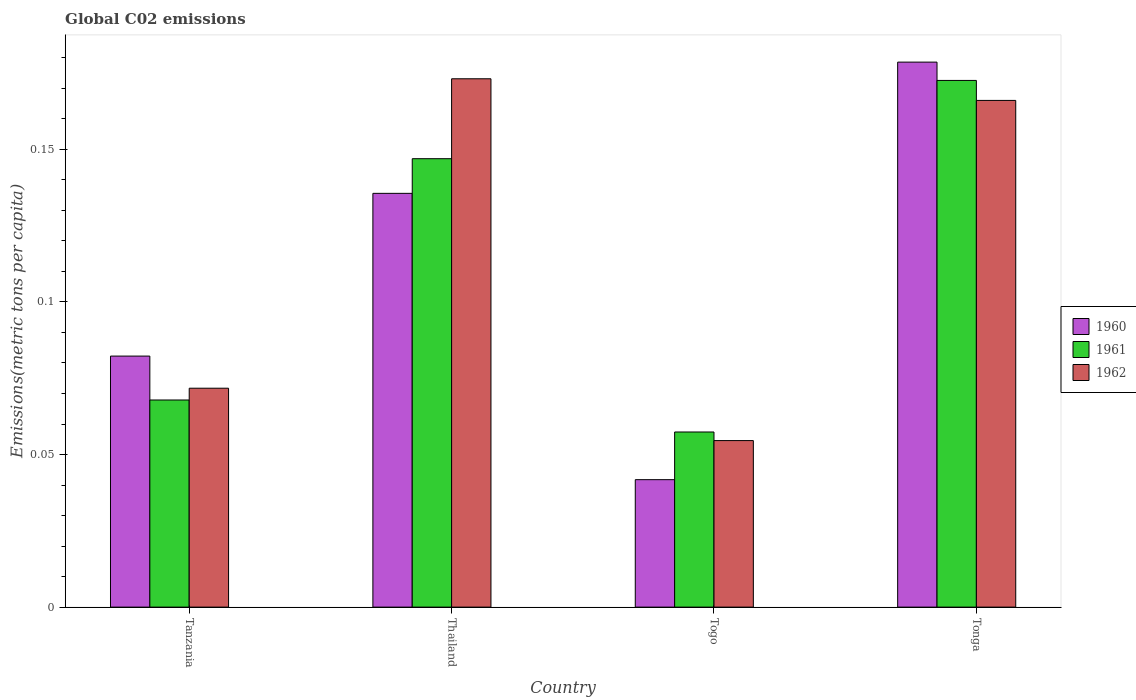How many different coloured bars are there?
Provide a succinct answer. 3. Are the number of bars on each tick of the X-axis equal?
Ensure brevity in your answer.  Yes. How many bars are there on the 1st tick from the left?
Your response must be concise. 3. How many bars are there on the 2nd tick from the right?
Give a very brief answer. 3. What is the label of the 4th group of bars from the left?
Provide a short and direct response. Tonga. In how many cases, is the number of bars for a given country not equal to the number of legend labels?
Keep it short and to the point. 0. What is the amount of CO2 emitted in in 1961 in Thailand?
Make the answer very short. 0.15. Across all countries, what is the maximum amount of CO2 emitted in in 1960?
Your answer should be compact. 0.18. Across all countries, what is the minimum amount of CO2 emitted in in 1962?
Your answer should be compact. 0.05. In which country was the amount of CO2 emitted in in 1961 maximum?
Keep it short and to the point. Tonga. In which country was the amount of CO2 emitted in in 1960 minimum?
Provide a succinct answer. Togo. What is the total amount of CO2 emitted in in 1961 in the graph?
Your answer should be very brief. 0.44. What is the difference between the amount of CO2 emitted in in 1962 in Thailand and that in Tonga?
Your answer should be compact. 0.01. What is the difference between the amount of CO2 emitted in in 1962 in Tonga and the amount of CO2 emitted in in 1960 in Thailand?
Provide a short and direct response. 0.03. What is the average amount of CO2 emitted in in 1961 per country?
Your answer should be very brief. 0.11. What is the difference between the amount of CO2 emitted in of/in 1961 and amount of CO2 emitted in of/in 1962 in Tonga?
Your answer should be very brief. 0.01. What is the ratio of the amount of CO2 emitted in in 1961 in Tanzania to that in Togo?
Keep it short and to the point. 1.18. Is the amount of CO2 emitted in in 1961 in Togo less than that in Tonga?
Offer a terse response. Yes. What is the difference between the highest and the second highest amount of CO2 emitted in in 1961?
Offer a very short reply. 0.1. What is the difference between the highest and the lowest amount of CO2 emitted in in 1962?
Your answer should be very brief. 0.12. In how many countries, is the amount of CO2 emitted in in 1960 greater than the average amount of CO2 emitted in in 1960 taken over all countries?
Keep it short and to the point. 2. What does the 3rd bar from the left in Togo represents?
Offer a terse response. 1962. What does the 3rd bar from the right in Tonga represents?
Offer a very short reply. 1960. How many bars are there?
Provide a succinct answer. 12. Are all the bars in the graph horizontal?
Provide a short and direct response. No. What is the difference between two consecutive major ticks on the Y-axis?
Your response must be concise. 0.05. Are the values on the major ticks of Y-axis written in scientific E-notation?
Keep it short and to the point. No. Does the graph contain any zero values?
Offer a very short reply. No. Does the graph contain grids?
Keep it short and to the point. No. Where does the legend appear in the graph?
Ensure brevity in your answer.  Center right. How many legend labels are there?
Offer a very short reply. 3. How are the legend labels stacked?
Your answer should be compact. Vertical. What is the title of the graph?
Offer a terse response. Global C02 emissions. What is the label or title of the Y-axis?
Your response must be concise. Emissions(metric tons per capita). What is the Emissions(metric tons per capita) in 1960 in Tanzania?
Your answer should be very brief. 0.08. What is the Emissions(metric tons per capita) of 1961 in Tanzania?
Give a very brief answer. 0.07. What is the Emissions(metric tons per capita) in 1962 in Tanzania?
Your response must be concise. 0.07. What is the Emissions(metric tons per capita) in 1960 in Thailand?
Offer a very short reply. 0.14. What is the Emissions(metric tons per capita) in 1961 in Thailand?
Make the answer very short. 0.15. What is the Emissions(metric tons per capita) in 1962 in Thailand?
Your answer should be compact. 0.17. What is the Emissions(metric tons per capita) of 1960 in Togo?
Your answer should be very brief. 0.04. What is the Emissions(metric tons per capita) of 1961 in Togo?
Your answer should be compact. 0.06. What is the Emissions(metric tons per capita) in 1962 in Togo?
Provide a succinct answer. 0.05. What is the Emissions(metric tons per capita) in 1960 in Tonga?
Offer a terse response. 0.18. What is the Emissions(metric tons per capita) in 1961 in Tonga?
Your answer should be very brief. 0.17. What is the Emissions(metric tons per capita) of 1962 in Tonga?
Ensure brevity in your answer.  0.17. Across all countries, what is the maximum Emissions(metric tons per capita) in 1960?
Keep it short and to the point. 0.18. Across all countries, what is the maximum Emissions(metric tons per capita) in 1961?
Keep it short and to the point. 0.17. Across all countries, what is the maximum Emissions(metric tons per capita) in 1962?
Make the answer very short. 0.17. Across all countries, what is the minimum Emissions(metric tons per capita) of 1960?
Provide a short and direct response. 0.04. Across all countries, what is the minimum Emissions(metric tons per capita) in 1961?
Your answer should be very brief. 0.06. Across all countries, what is the minimum Emissions(metric tons per capita) of 1962?
Your response must be concise. 0.05. What is the total Emissions(metric tons per capita) of 1960 in the graph?
Give a very brief answer. 0.44. What is the total Emissions(metric tons per capita) in 1961 in the graph?
Provide a short and direct response. 0.44. What is the total Emissions(metric tons per capita) of 1962 in the graph?
Keep it short and to the point. 0.47. What is the difference between the Emissions(metric tons per capita) of 1960 in Tanzania and that in Thailand?
Give a very brief answer. -0.05. What is the difference between the Emissions(metric tons per capita) of 1961 in Tanzania and that in Thailand?
Your answer should be very brief. -0.08. What is the difference between the Emissions(metric tons per capita) of 1962 in Tanzania and that in Thailand?
Give a very brief answer. -0.1. What is the difference between the Emissions(metric tons per capita) of 1960 in Tanzania and that in Togo?
Give a very brief answer. 0.04. What is the difference between the Emissions(metric tons per capita) in 1961 in Tanzania and that in Togo?
Make the answer very short. 0.01. What is the difference between the Emissions(metric tons per capita) of 1962 in Tanzania and that in Togo?
Make the answer very short. 0.02. What is the difference between the Emissions(metric tons per capita) in 1960 in Tanzania and that in Tonga?
Make the answer very short. -0.1. What is the difference between the Emissions(metric tons per capita) of 1961 in Tanzania and that in Tonga?
Offer a terse response. -0.1. What is the difference between the Emissions(metric tons per capita) in 1962 in Tanzania and that in Tonga?
Your response must be concise. -0.09. What is the difference between the Emissions(metric tons per capita) in 1960 in Thailand and that in Togo?
Give a very brief answer. 0.09. What is the difference between the Emissions(metric tons per capita) of 1961 in Thailand and that in Togo?
Give a very brief answer. 0.09. What is the difference between the Emissions(metric tons per capita) of 1962 in Thailand and that in Togo?
Provide a short and direct response. 0.12. What is the difference between the Emissions(metric tons per capita) of 1960 in Thailand and that in Tonga?
Your answer should be compact. -0.04. What is the difference between the Emissions(metric tons per capita) in 1961 in Thailand and that in Tonga?
Ensure brevity in your answer.  -0.03. What is the difference between the Emissions(metric tons per capita) in 1962 in Thailand and that in Tonga?
Provide a short and direct response. 0.01. What is the difference between the Emissions(metric tons per capita) of 1960 in Togo and that in Tonga?
Provide a short and direct response. -0.14. What is the difference between the Emissions(metric tons per capita) of 1961 in Togo and that in Tonga?
Your answer should be compact. -0.12. What is the difference between the Emissions(metric tons per capita) in 1962 in Togo and that in Tonga?
Make the answer very short. -0.11. What is the difference between the Emissions(metric tons per capita) of 1960 in Tanzania and the Emissions(metric tons per capita) of 1961 in Thailand?
Your answer should be very brief. -0.06. What is the difference between the Emissions(metric tons per capita) of 1960 in Tanzania and the Emissions(metric tons per capita) of 1962 in Thailand?
Give a very brief answer. -0.09. What is the difference between the Emissions(metric tons per capita) in 1961 in Tanzania and the Emissions(metric tons per capita) in 1962 in Thailand?
Provide a short and direct response. -0.11. What is the difference between the Emissions(metric tons per capita) of 1960 in Tanzania and the Emissions(metric tons per capita) of 1961 in Togo?
Give a very brief answer. 0.02. What is the difference between the Emissions(metric tons per capita) of 1960 in Tanzania and the Emissions(metric tons per capita) of 1962 in Togo?
Ensure brevity in your answer.  0.03. What is the difference between the Emissions(metric tons per capita) of 1961 in Tanzania and the Emissions(metric tons per capita) of 1962 in Togo?
Make the answer very short. 0.01. What is the difference between the Emissions(metric tons per capita) in 1960 in Tanzania and the Emissions(metric tons per capita) in 1961 in Tonga?
Your response must be concise. -0.09. What is the difference between the Emissions(metric tons per capita) of 1960 in Tanzania and the Emissions(metric tons per capita) of 1962 in Tonga?
Offer a very short reply. -0.08. What is the difference between the Emissions(metric tons per capita) in 1961 in Tanzania and the Emissions(metric tons per capita) in 1962 in Tonga?
Your answer should be very brief. -0.1. What is the difference between the Emissions(metric tons per capita) of 1960 in Thailand and the Emissions(metric tons per capita) of 1961 in Togo?
Provide a succinct answer. 0.08. What is the difference between the Emissions(metric tons per capita) of 1960 in Thailand and the Emissions(metric tons per capita) of 1962 in Togo?
Offer a terse response. 0.08. What is the difference between the Emissions(metric tons per capita) in 1961 in Thailand and the Emissions(metric tons per capita) in 1962 in Togo?
Provide a succinct answer. 0.09. What is the difference between the Emissions(metric tons per capita) of 1960 in Thailand and the Emissions(metric tons per capita) of 1961 in Tonga?
Make the answer very short. -0.04. What is the difference between the Emissions(metric tons per capita) in 1960 in Thailand and the Emissions(metric tons per capita) in 1962 in Tonga?
Provide a short and direct response. -0.03. What is the difference between the Emissions(metric tons per capita) of 1961 in Thailand and the Emissions(metric tons per capita) of 1962 in Tonga?
Your answer should be compact. -0.02. What is the difference between the Emissions(metric tons per capita) in 1960 in Togo and the Emissions(metric tons per capita) in 1961 in Tonga?
Keep it short and to the point. -0.13. What is the difference between the Emissions(metric tons per capita) in 1960 in Togo and the Emissions(metric tons per capita) in 1962 in Tonga?
Your answer should be very brief. -0.12. What is the difference between the Emissions(metric tons per capita) in 1961 in Togo and the Emissions(metric tons per capita) in 1962 in Tonga?
Your answer should be very brief. -0.11. What is the average Emissions(metric tons per capita) of 1960 per country?
Give a very brief answer. 0.11. What is the average Emissions(metric tons per capita) in 1961 per country?
Make the answer very short. 0.11. What is the average Emissions(metric tons per capita) in 1962 per country?
Offer a very short reply. 0.12. What is the difference between the Emissions(metric tons per capita) of 1960 and Emissions(metric tons per capita) of 1961 in Tanzania?
Provide a short and direct response. 0.01. What is the difference between the Emissions(metric tons per capita) of 1960 and Emissions(metric tons per capita) of 1962 in Tanzania?
Provide a succinct answer. 0.01. What is the difference between the Emissions(metric tons per capita) of 1961 and Emissions(metric tons per capita) of 1962 in Tanzania?
Keep it short and to the point. -0. What is the difference between the Emissions(metric tons per capita) in 1960 and Emissions(metric tons per capita) in 1961 in Thailand?
Offer a very short reply. -0.01. What is the difference between the Emissions(metric tons per capita) in 1960 and Emissions(metric tons per capita) in 1962 in Thailand?
Provide a short and direct response. -0.04. What is the difference between the Emissions(metric tons per capita) of 1961 and Emissions(metric tons per capita) of 1962 in Thailand?
Keep it short and to the point. -0.03. What is the difference between the Emissions(metric tons per capita) of 1960 and Emissions(metric tons per capita) of 1961 in Togo?
Keep it short and to the point. -0.02. What is the difference between the Emissions(metric tons per capita) in 1960 and Emissions(metric tons per capita) in 1962 in Togo?
Keep it short and to the point. -0.01. What is the difference between the Emissions(metric tons per capita) in 1961 and Emissions(metric tons per capita) in 1962 in Togo?
Your response must be concise. 0. What is the difference between the Emissions(metric tons per capita) of 1960 and Emissions(metric tons per capita) of 1961 in Tonga?
Offer a terse response. 0.01. What is the difference between the Emissions(metric tons per capita) in 1960 and Emissions(metric tons per capita) in 1962 in Tonga?
Offer a terse response. 0.01. What is the difference between the Emissions(metric tons per capita) of 1961 and Emissions(metric tons per capita) of 1962 in Tonga?
Your response must be concise. 0.01. What is the ratio of the Emissions(metric tons per capita) in 1960 in Tanzania to that in Thailand?
Give a very brief answer. 0.61. What is the ratio of the Emissions(metric tons per capita) of 1961 in Tanzania to that in Thailand?
Your answer should be compact. 0.46. What is the ratio of the Emissions(metric tons per capita) of 1962 in Tanzania to that in Thailand?
Ensure brevity in your answer.  0.41. What is the ratio of the Emissions(metric tons per capita) of 1960 in Tanzania to that in Togo?
Give a very brief answer. 1.97. What is the ratio of the Emissions(metric tons per capita) of 1961 in Tanzania to that in Togo?
Your response must be concise. 1.18. What is the ratio of the Emissions(metric tons per capita) of 1962 in Tanzania to that in Togo?
Make the answer very short. 1.31. What is the ratio of the Emissions(metric tons per capita) of 1960 in Tanzania to that in Tonga?
Offer a terse response. 0.46. What is the ratio of the Emissions(metric tons per capita) in 1961 in Tanzania to that in Tonga?
Offer a very short reply. 0.39. What is the ratio of the Emissions(metric tons per capita) in 1962 in Tanzania to that in Tonga?
Offer a very short reply. 0.43. What is the ratio of the Emissions(metric tons per capita) of 1960 in Thailand to that in Togo?
Make the answer very short. 3.25. What is the ratio of the Emissions(metric tons per capita) in 1961 in Thailand to that in Togo?
Your answer should be compact. 2.56. What is the ratio of the Emissions(metric tons per capita) of 1962 in Thailand to that in Togo?
Provide a short and direct response. 3.17. What is the ratio of the Emissions(metric tons per capita) of 1960 in Thailand to that in Tonga?
Give a very brief answer. 0.76. What is the ratio of the Emissions(metric tons per capita) of 1961 in Thailand to that in Tonga?
Provide a short and direct response. 0.85. What is the ratio of the Emissions(metric tons per capita) of 1962 in Thailand to that in Tonga?
Provide a short and direct response. 1.04. What is the ratio of the Emissions(metric tons per capita) in 1960 in Togo to that in Tonga?
Offer a very short reply. 0.23. What is the ratio of the Emissions(metric tons per capita) of 1961 in Togo to that in Tonga?
Give a very brief answer. 0.33. What is the ratio of the Emissions(metric tons per capita) of 1962 in Togo to that in Tonga?
Provide a short and direct response. 0.33. What is the difference between the highest and the second highest Emissions(metric tons per capita) of 1960?
Offer a very short reply. 0.04. What is the difference between the highest and the second highest Emissions(metric tons per capita) of 1961?
Offer a terse response. 0.03. What is the difference between the highest and the second highest Emissions(metric tons per capita) in 1962?
Your answer should be very brief. 0.01. What is the difference between the highest and the lowest Emissions(metric tons per capita) of 1960?
Your answer should be very brief. 0.14. What is the difference between the highest and the lowest Emissions(metric tons per capita) in 1961?
Offer a terse response. 0.12. What is the difference between the highest and the lowest Emissions(metric tons per capita) in 1962?
Offer a very short reply. 0.12. 